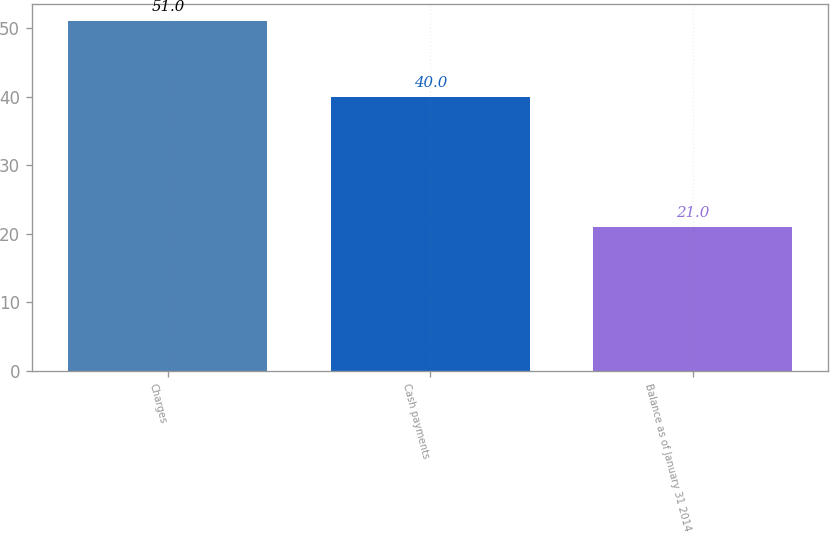<chart> <loc_0><loc_0><loc_500><loc_500><bar_chart><fcel>Charges<fcel>Cash payments<fcel>Balance as of January 31 2014<nl><fcel>51<fcel>40<fcel>21<nl></chart> 